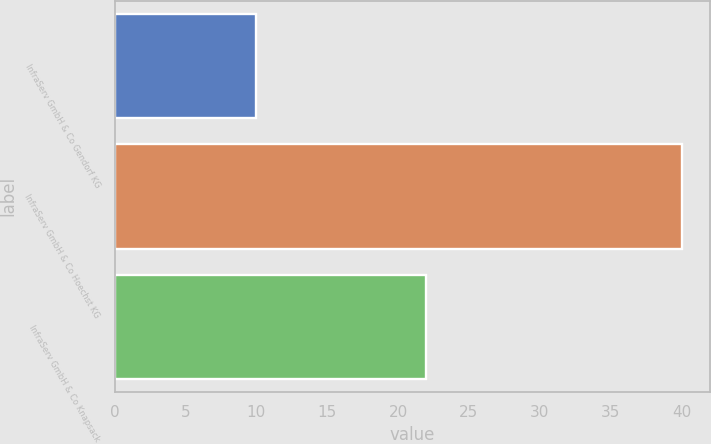Convert chart to OTSL. <chart><loc_0><loc_0><loc_500><loc_500><bar_chart><fcel>InfraServ GmbH & Co Gendorf KG<fcel>InfraServ GmbH & Co Hoechst KG<fcel>InfraServ GmbH & Co Knapsack<nl><fcel>10<fcel>40<fcel>22<nl></chart> 